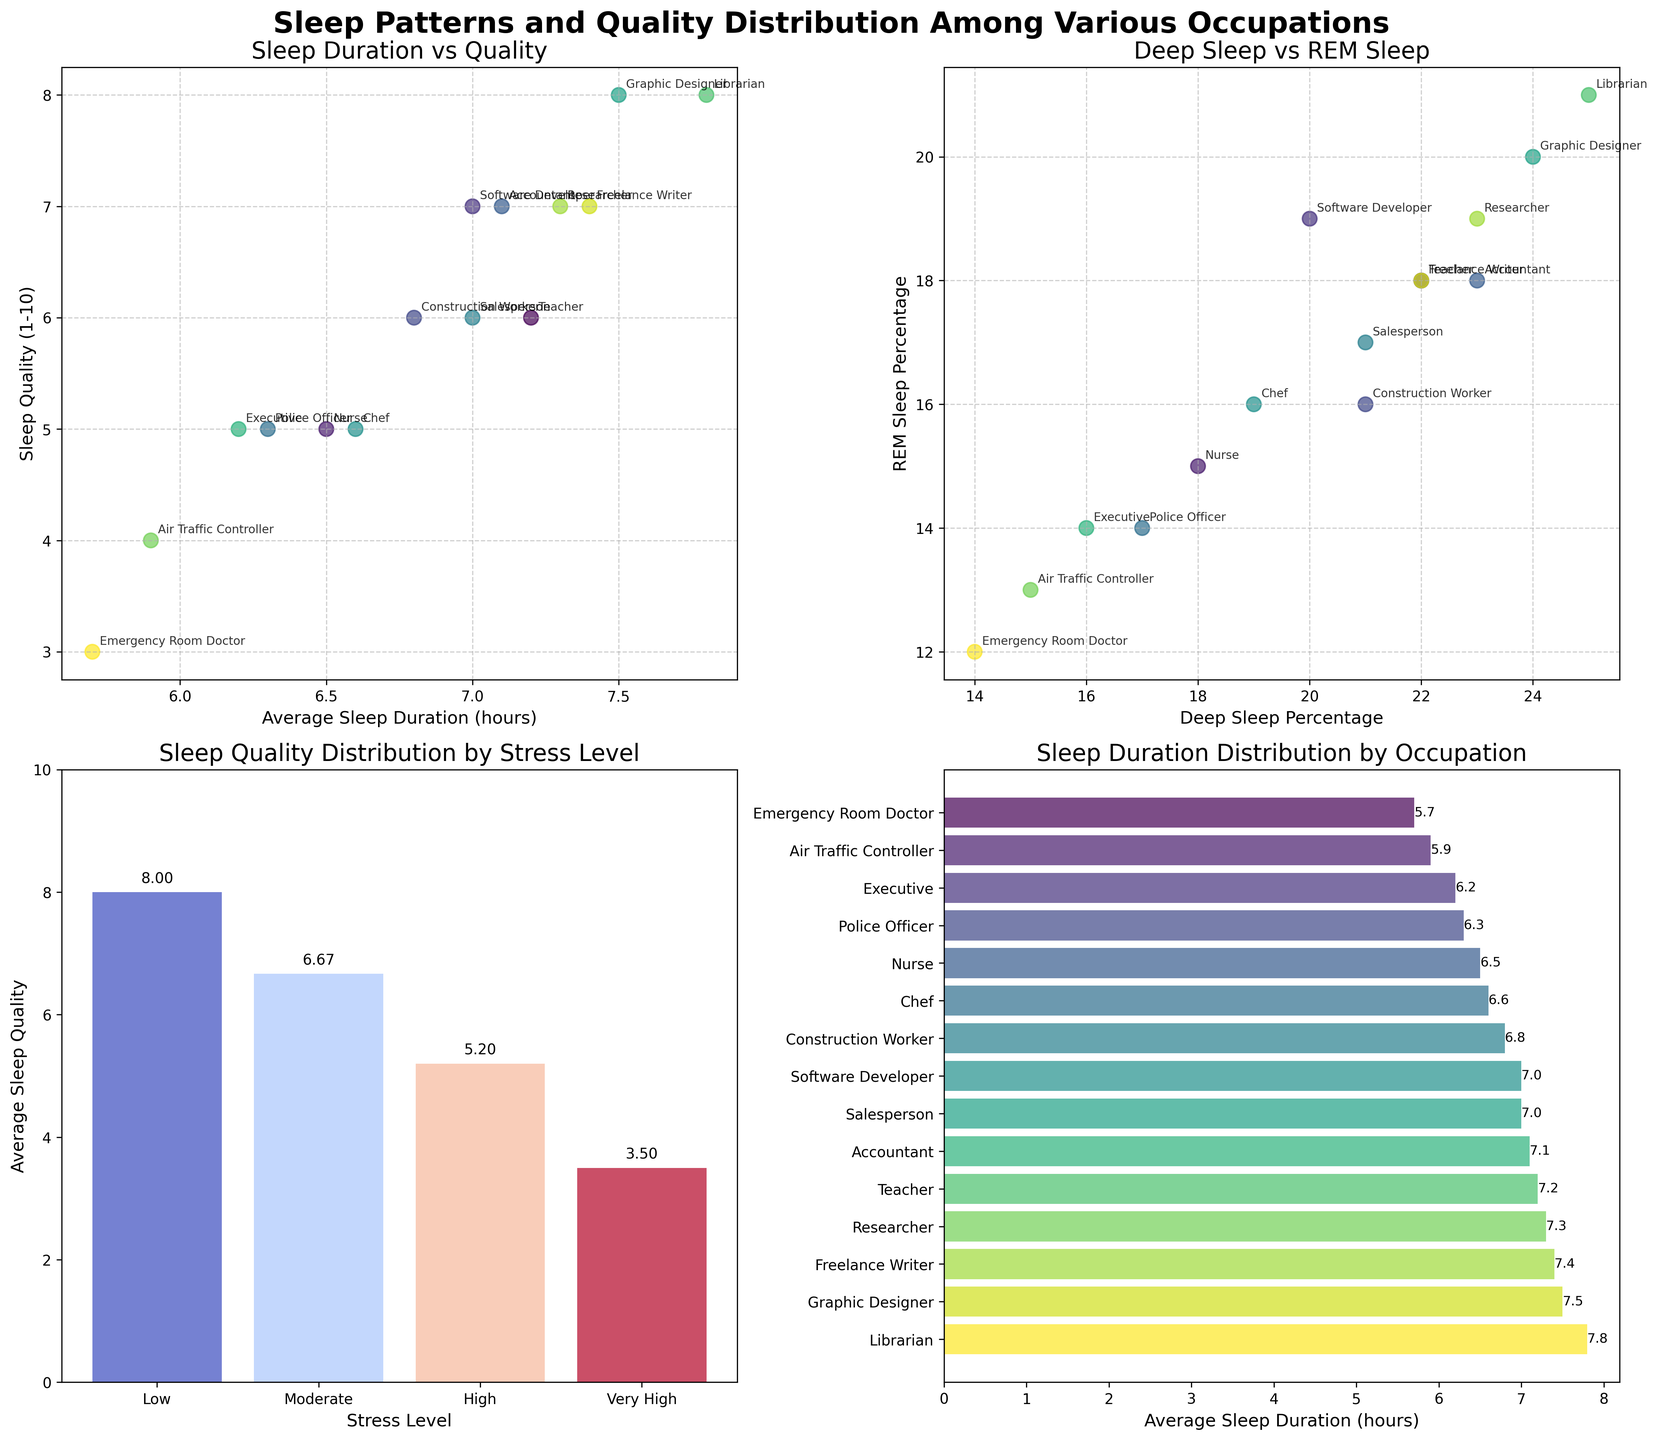How many data points are displayed in the "Sleep Duration vs Quality" plot? Each occupation in the dataset represents one data point, and there are 15 different occupations listed. Therefore, the plot should have 15 data points.
Answer: 15 Which occupation has the highest average sleep duration? In the "Sleep Duration Distribution by Occupation" plot, the data bars are sorted by average sleep duration. The bar at the top represents the highest value, which corresponds to the Librarian.
Answer: Librarian What is the average sleep quality for teachers? On the "Sleep Duration vs Quality" plot, locate the point labeled "Teacher" on the sleep quality axis. The value is 6.
Answer: 6 What is the difference in average sleep quality between occupations with low and very high stress levels? In the "Sleep Quality Distribution by Stress Level" plot, the average sleep quality for low stress is 8, and for very high stress, it is 3. So, the difference is 8 - 3 = 5.
Answer: 5 Compare the REM sleep percentages of the occupations with the highest and lowest sleep quality. In the "Sleep Duration vs Quality" plot, the highest sleep quality is 8 (Librarian), and the lowest is 3 (Emergency Room Doctor). In the "Deep Sleep vs REM Sleep" plot, Librarian has 21% REM sleep, and Emergency Room Doctor has 12% REM sleep.
Answer: Librarian: 21%, Emergency Room Doctor: 12% What is the title of the subplot that shows the relationship between deep sleep percentage and REM sleep percentage? The title of the second subplot on the top row is "Deep Sleep vs REM Sleep."
Answer: Deep Sleep vs REM Sleep Which occupation has the lowest sleep quality, and what is its average sleep duration? In the "Sleep Duration vs Quality" plot, the point with the lowest sleep quality is labeled "Emergency Room Doctor" with a sleep quality of 3. The average sleep duration for this occupation is found in the same plot as 5.7 hours.
Answer: Emergency Room Doctor, 5.7 hours Based on the plots, what can you infer about the relationship between stress level and sleep quality? The "Sleep Quality Distribution by Stress Level" plot shows that as stress levels increase from low to very high, the average sleep quality decreases. This suggests a negative correlation between stress level and sleep quality.
Answer: Negative relationship Which occupations have the closest average sleep durations? In the "Sleep Duration Distribution by Occupation" plot, the bars for "Teacher" (7.2 hours) and "Accountant" (7.1 hours) are very close to each other.
Answer: Teacher and Accountant 